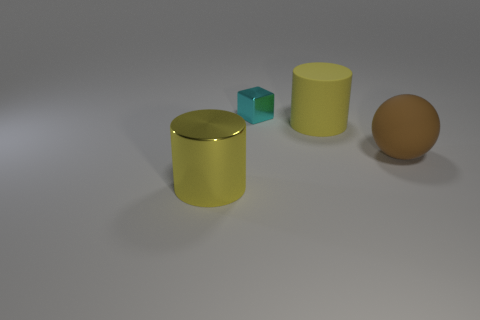Add 3 large brown spheres. How many objects exist? 7 Subtract all blocks. How many objects are left? 3 Subtract 1 brown spheres. How many objects are left? 3 Subtract all big yellow rubber cylinders. Subtract all large yellow shiny things. How many objects are left? 2 Add 3 cyan blocks. How many cyan blocks are left? 4 Add 1 large yellow shiny objects. How many large yellow shiny objects exist? 2 